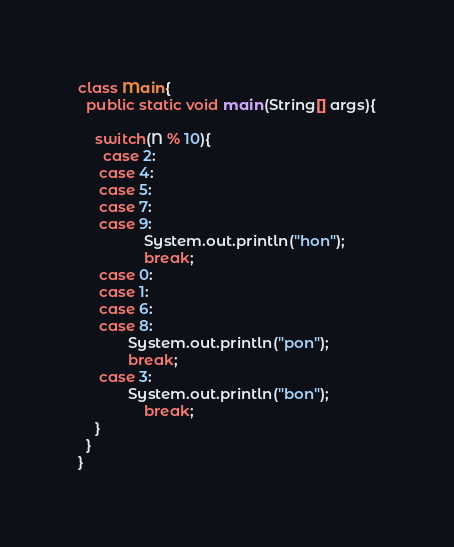<code> <loc_0><loc_0><loc_500><loc_500><_Java_>class Main{
  public static void main(String[] args){
    
    switch(N % 10){
      case 2:
     case 4:
     case 5:
     case 7:
     case 9:
    			System.out.println("hon");
    			break;
     case 0:
     case 1:
     case 6:
     case 8:
    		System.out.println("pon");
    		break;
     case 3:
     		System.out.println("bon");
    			break;
    }
  }
}</code> 